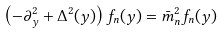Convert formula to latex. <formula><loc_0><loc_0><loc_500><loc_500>\left ( - \partial ^ { 2 } _ { y } + \Delta ^ { 2 } ( y ) \right ) f _ { n } ( y ) = \bar { m } ^ { 2 } _ { n } f _ { n } ( y )</formula> 